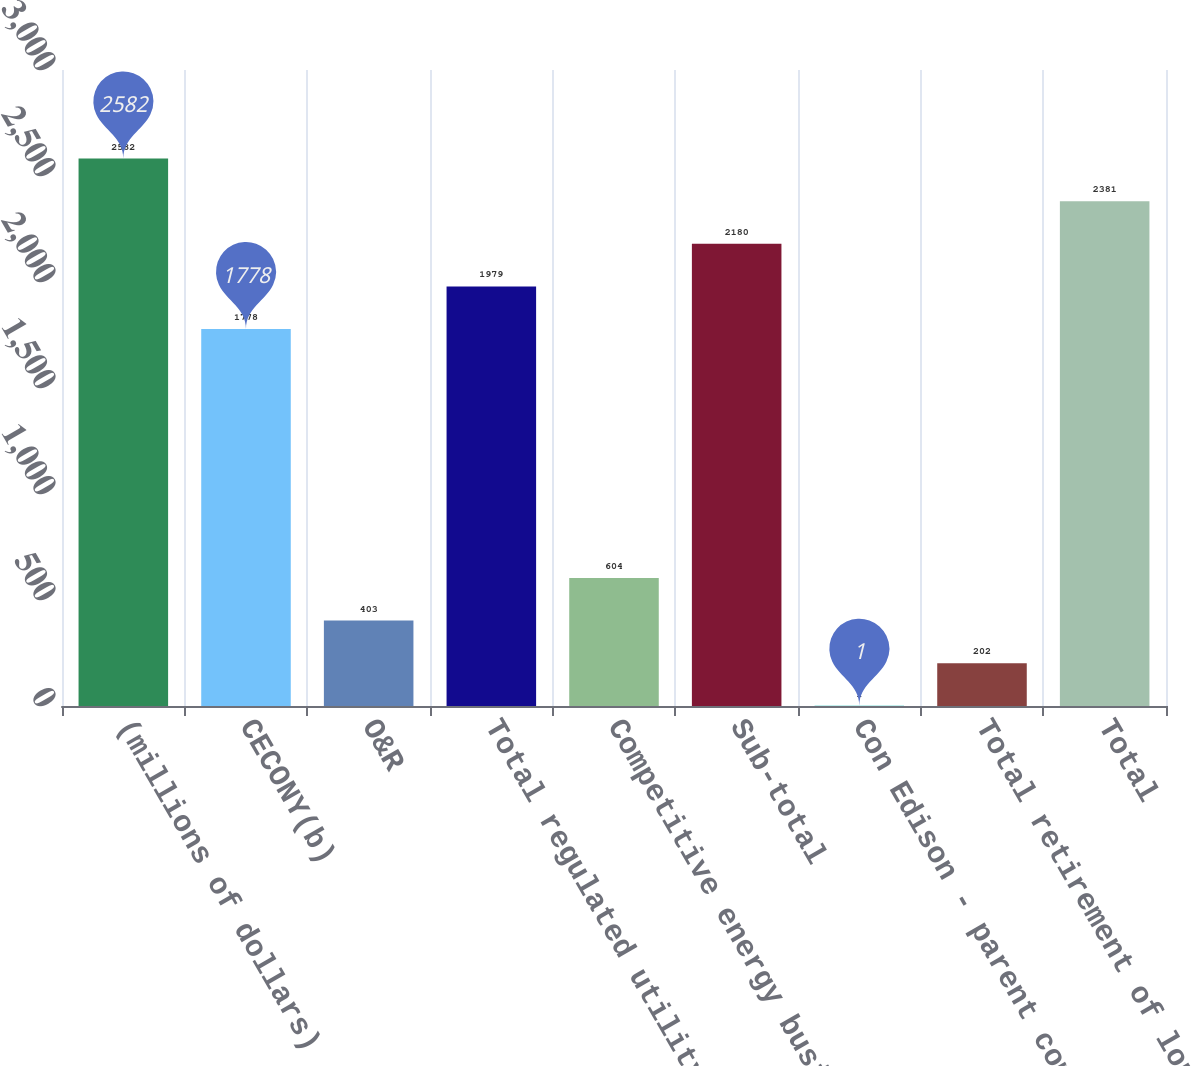Convert chart to OTSL. <chart><loc_0><loc_0><loc_500><loc_500><bar_chart><fcel>(millions of dollars)<fcel>CECONY(b)<fcel>O&R<fcel>Total regulated utility<fcel>Competitive energy businesses<fcel>Sub-total<fcel>Con Edison - parent company<fcel>Total retirement of long-term<fcel>Total<nl><fcel>2582<fcel>1778<fcel>403<fcel>1979<fcel>604<fcel>2180<fcel>1<fcel>202<fcel>2381<nl></chart> 